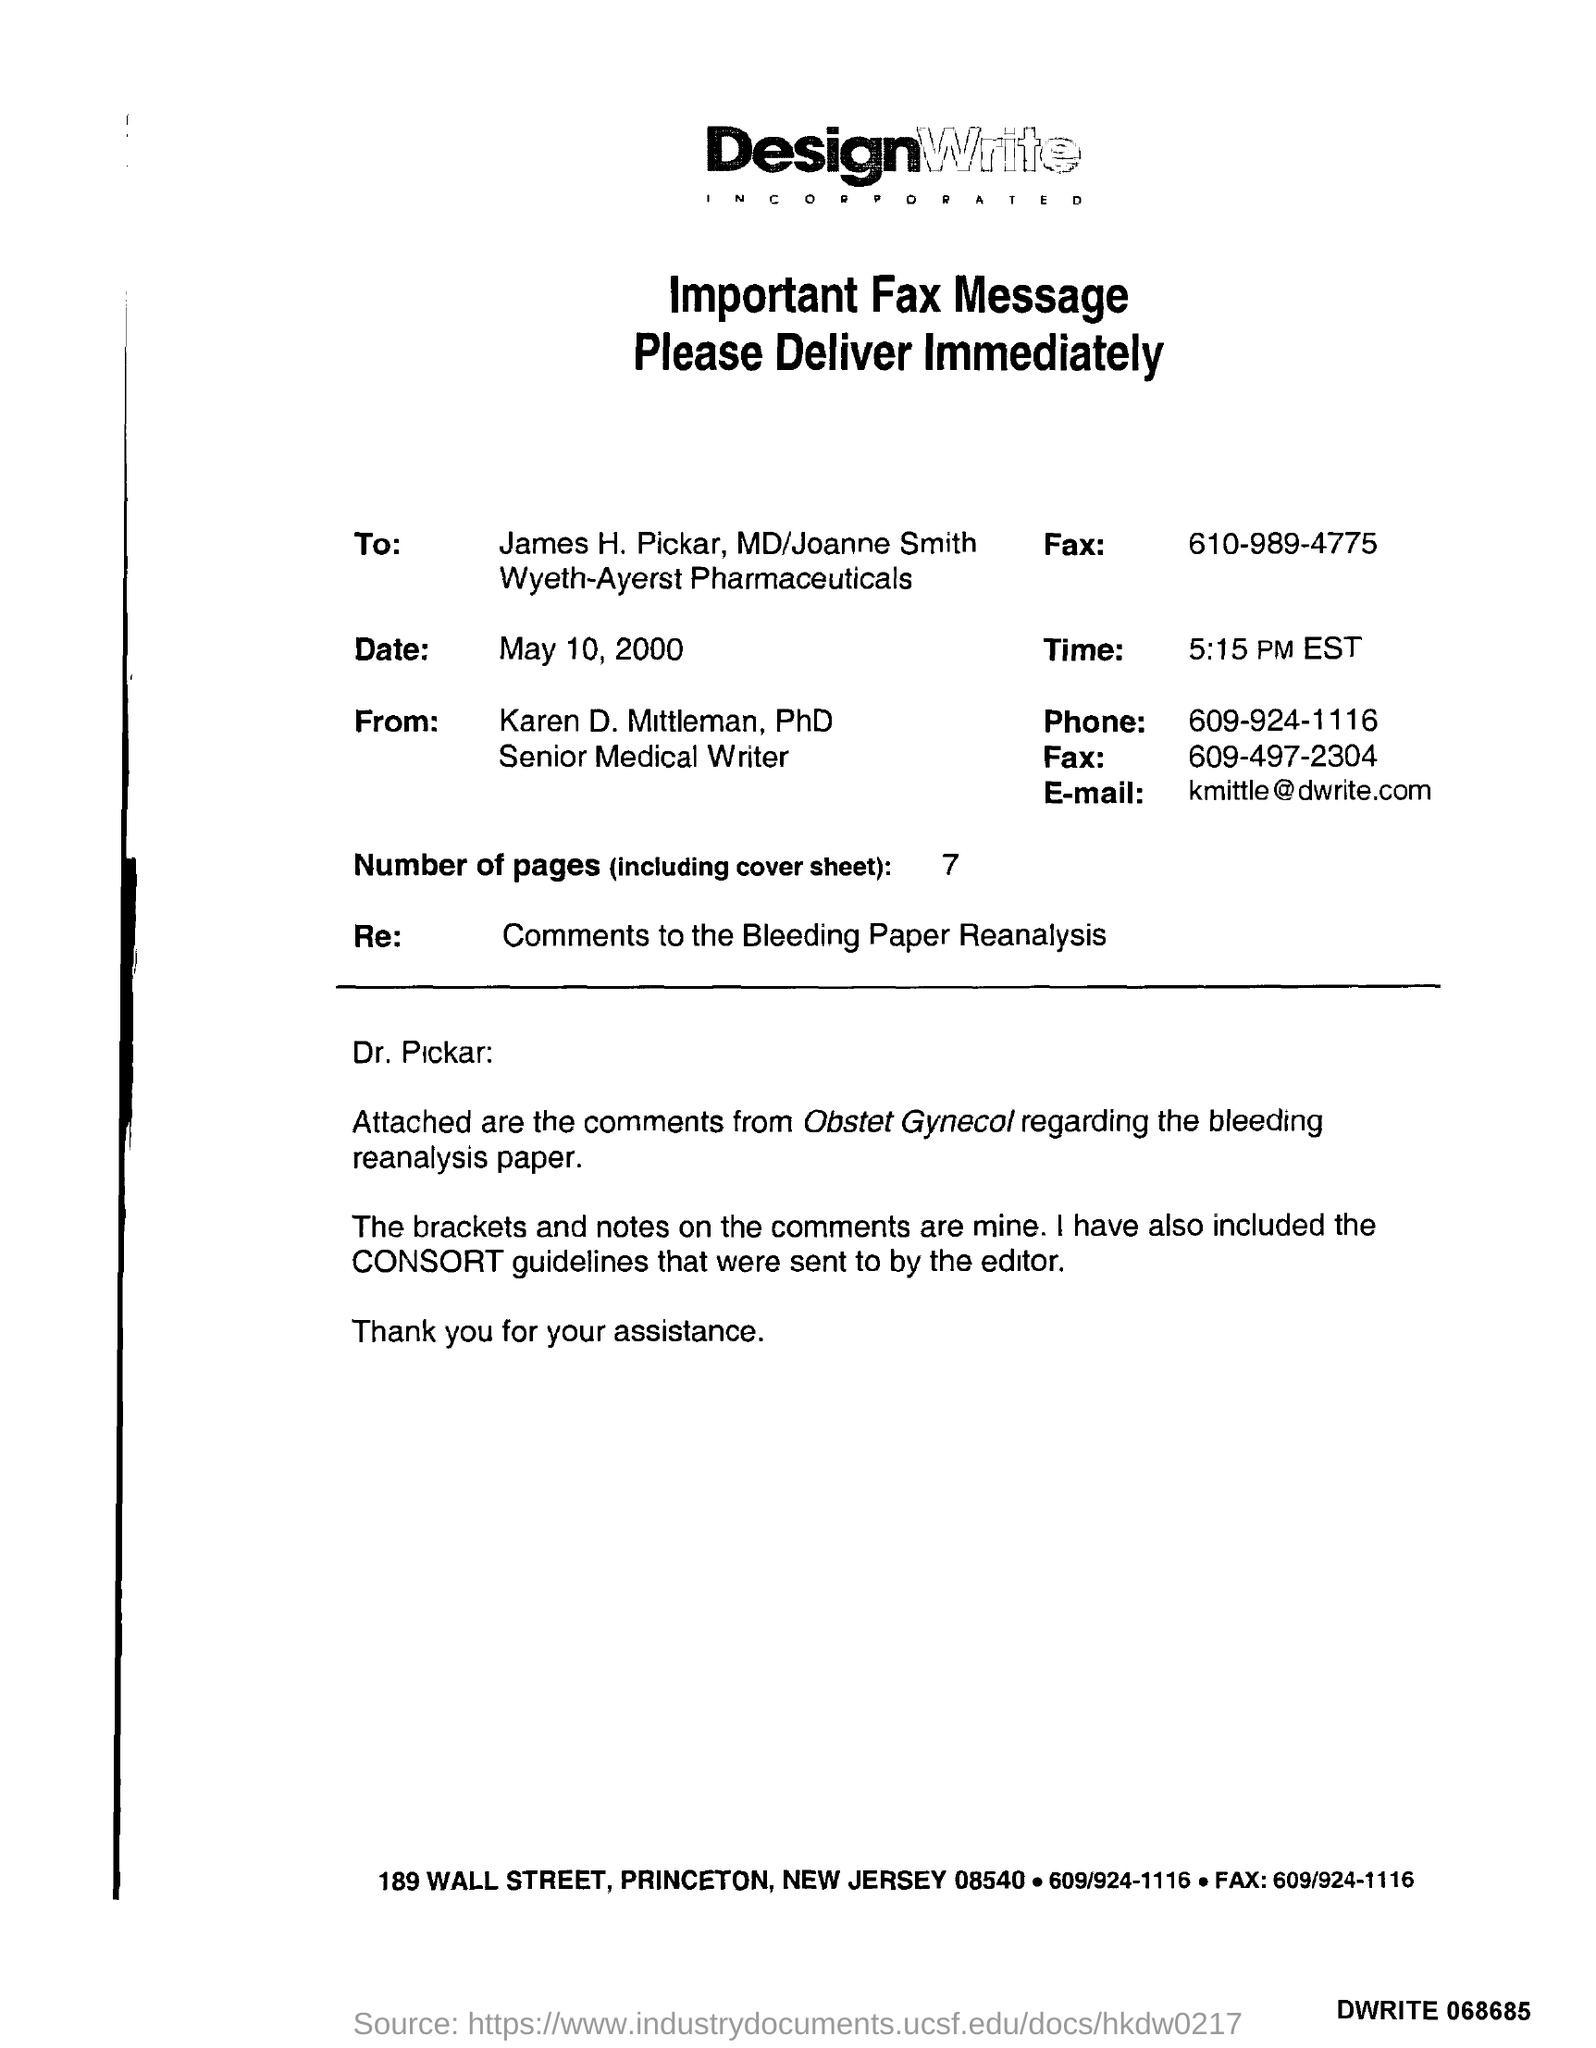Outline some significant characteristics in this image. The editor received guidelines from the consort regarding the consort's sentencing. 